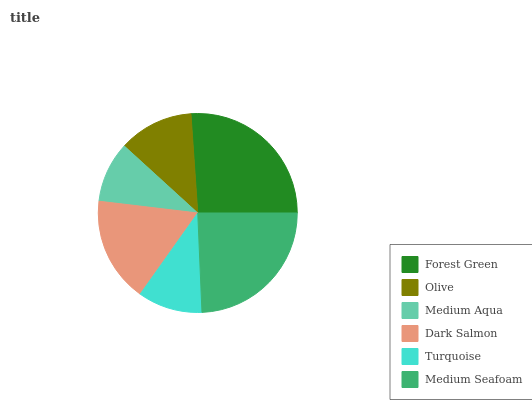Is Medium Aqua the minimum?
Answer yes or no. Yes. Is Forest Green the maximum?
Answer yes or no. Yes. Is Olive the minimum?
Answer yes or no. No. Is Olive the maximum?
Answer yes or no. No. Is Forest Green greater than Olive?
Answer yes or no. Yes. Is Olive less than Forest Green?
Answer yes or no. Yes. Is Olive greater than Forest Green?
Answer yes or no. No. Is Forest Green less than Olive?
Answer yes or no. No. Is Dark Salmon the high median?
Answer yes or no. Yes. Is Olive the low median?
Answer yes or no. Yes. Is Turquoise the high median?
Answer yes or no. No. Is Turquoise the low median?
Answer yes or no. No. 